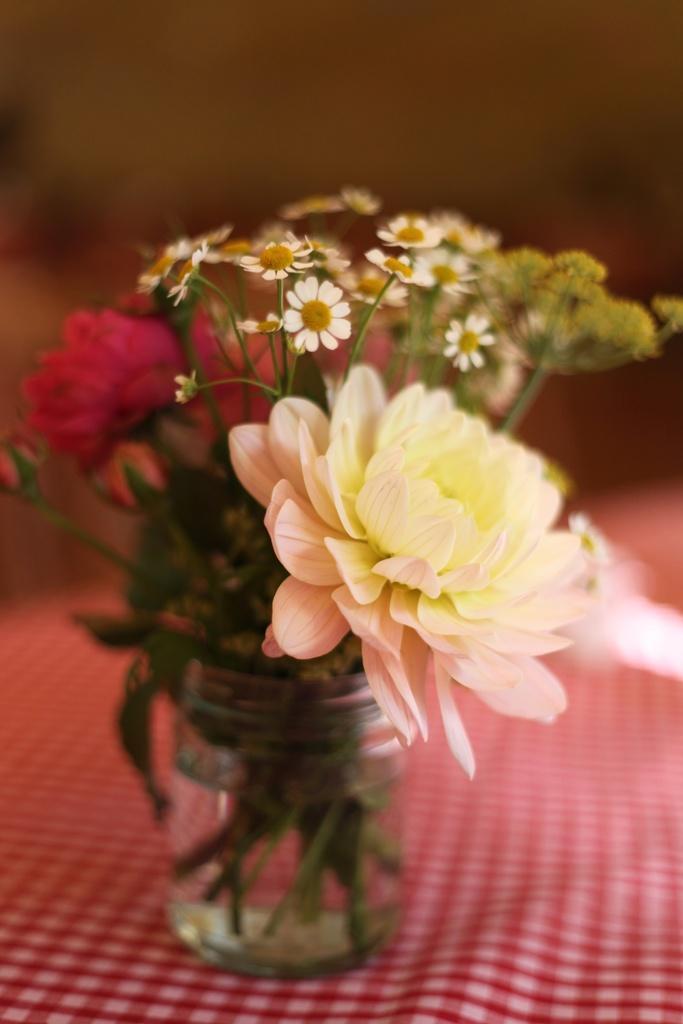Can you describe this image briefly? This image is taken indoors. In this image the background is a little blurred. At the bottom of the image there is a table with a tablecloth on it. In the middle of the image there is a flower vase with different colors of flowers on the table. 